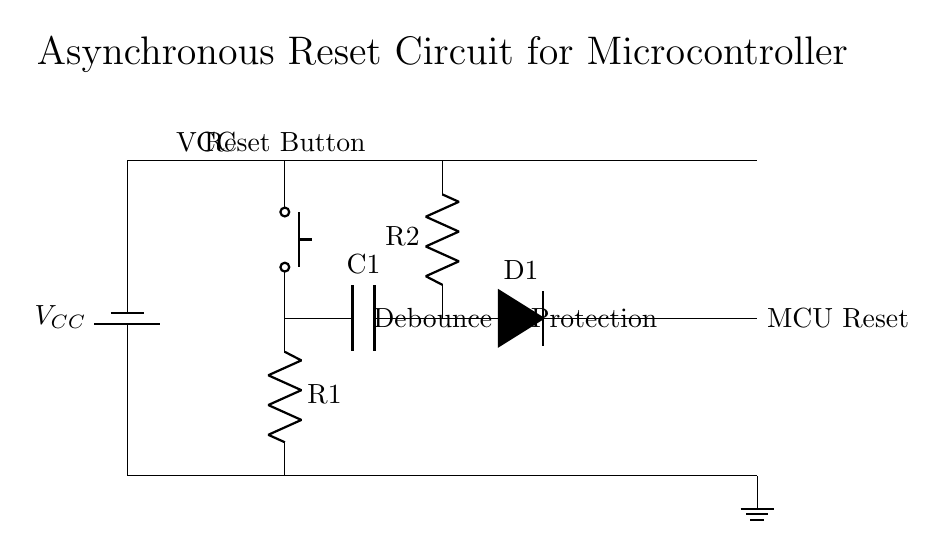What is the role of the push button in this circuit? The push button acts as a manual reset for the microcontroller, allowing the user to initialize or reset the system when pressed.
Answer: Manual reset What component is used for debounce in this circuit? The capacitor (C1) is used to smooth out the signal from the push button, preventing false triggers during mechanical bouncing when the button is pressed.
Answer: Capacitor What is the voltage source in this circuit? The voltage source is identified as VCC, which provides the necessary power for the circuit to operate.
Answer: VCC Which component provides protection in the circuit? The diode (D1) is responsible for protecting the microcontroller by allowing current to flow in only one direction and preventing reverse current.
Answer: Diode How many resistors are present in this circuit? There are two resistors in the circuit, R1 and R2, serving different purposes for the reset circuit and voltage division.
Answer: Two What happens when the reset button is pressed? Pressing the reset button completes the circuit, charging the capacitor and sending a reset signal to the microcontroller, thus restarting its operation.
Answer: Restart microcontroller What is the purpose of the resistor R2 in this circuit? The resistor R2 limits the current to the capacitor and ensures that it charges at a controlled rate, contributing to the debounce function.
Answer: Current limiting 